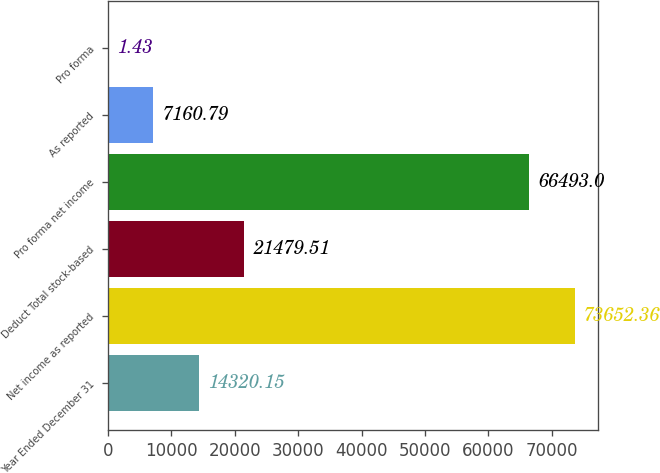Convert chart to OTSL. <chart><loc_0><loc_0><loc_500><loc_500><bar_chart><fcel>Year Ended December 31<fcel>Net income as reported<fcel>Deduct Total stock-based<fcel>Pro forma net income<fcel>As reported<fcel>Pro forma<nl><fcel>14320.1<fcel>73652.4<fcel>21479.5<fcel>66493<fcel>7160.79<fcel>1.43<nl></chart> 